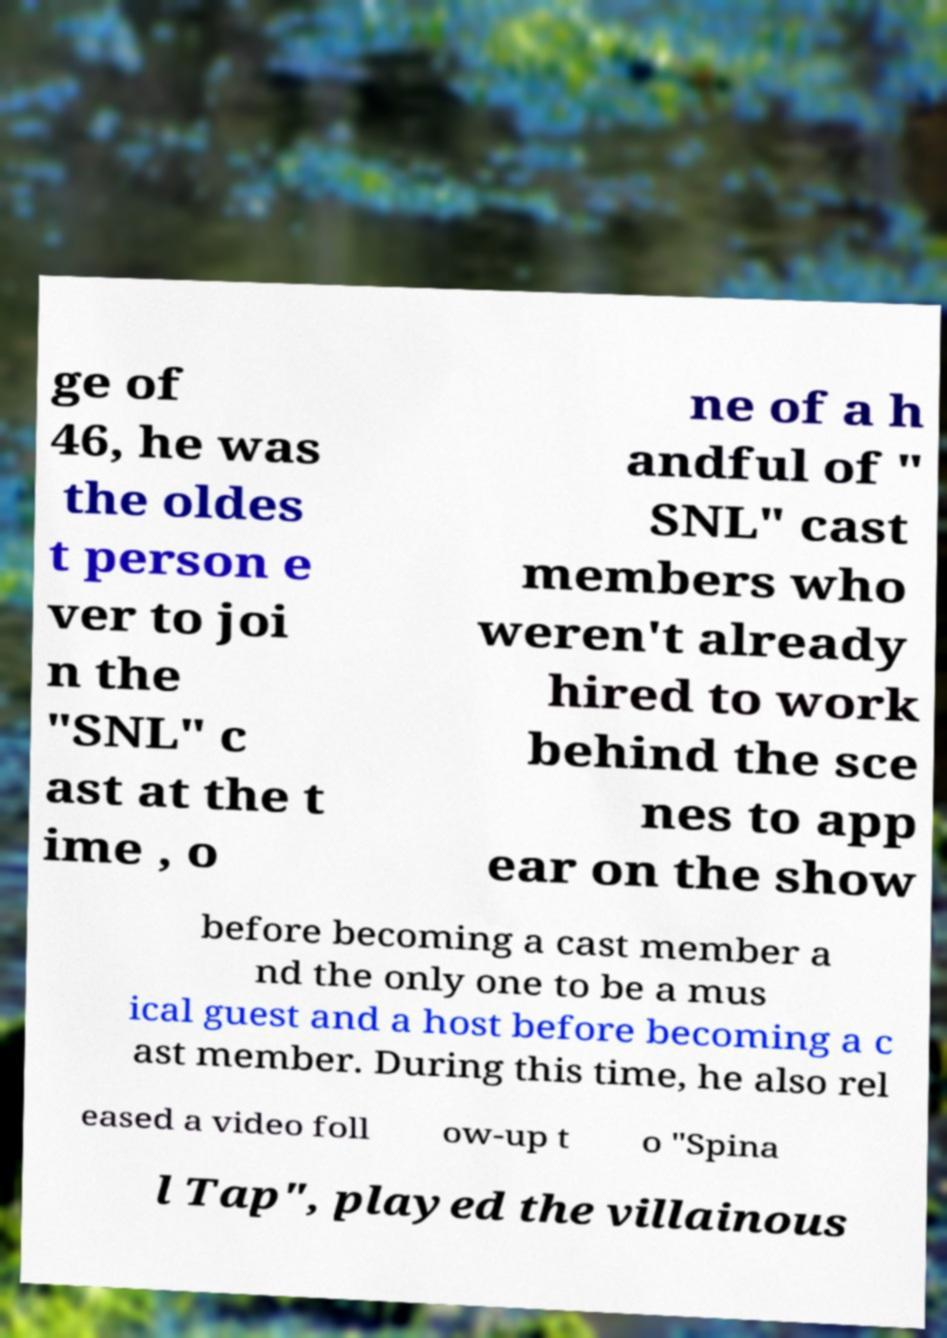Please read and relay the text visible in this image. What does it say? ge of 46, he was the oldes t person e ver to joi n the "SNL" c ast at the t ime , o ne of a h andful of " SNL" cast members who weren't already hired to work behind the sce nes to app ear on the show before becoming a cast member a nd the only one to be a mus ical guest and a host before becoming a c ast member. During this time, he also rel eased a video foll ow-up t o "Spina l Tap", played the villainous 